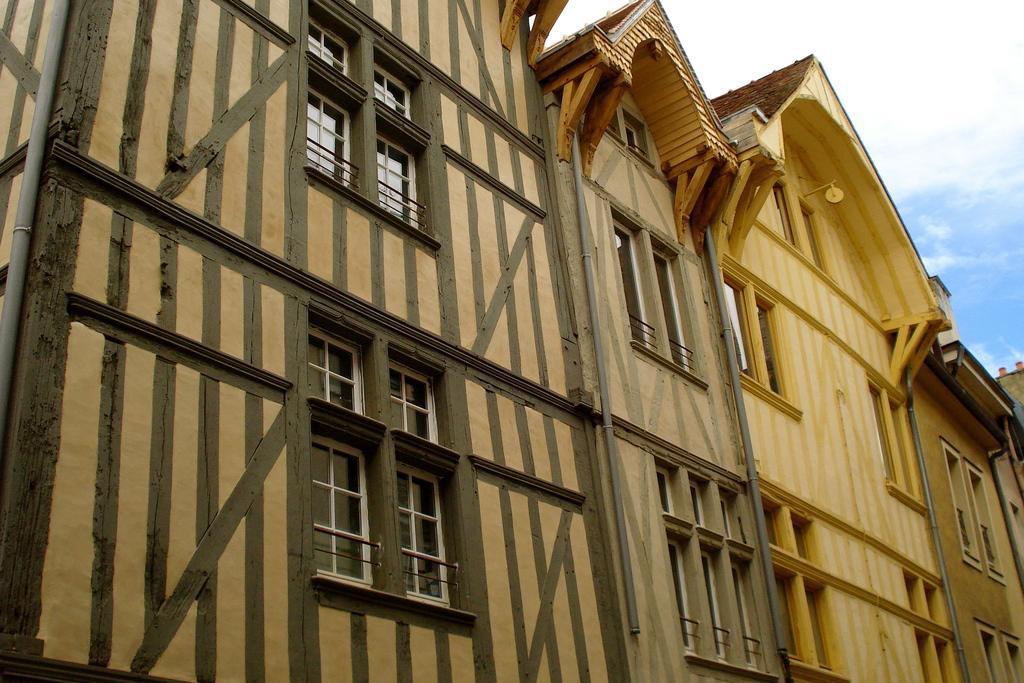Please provide a concise description of this image. In this image, we can see a few buildings. We can also see the sky and it is cloudy. 